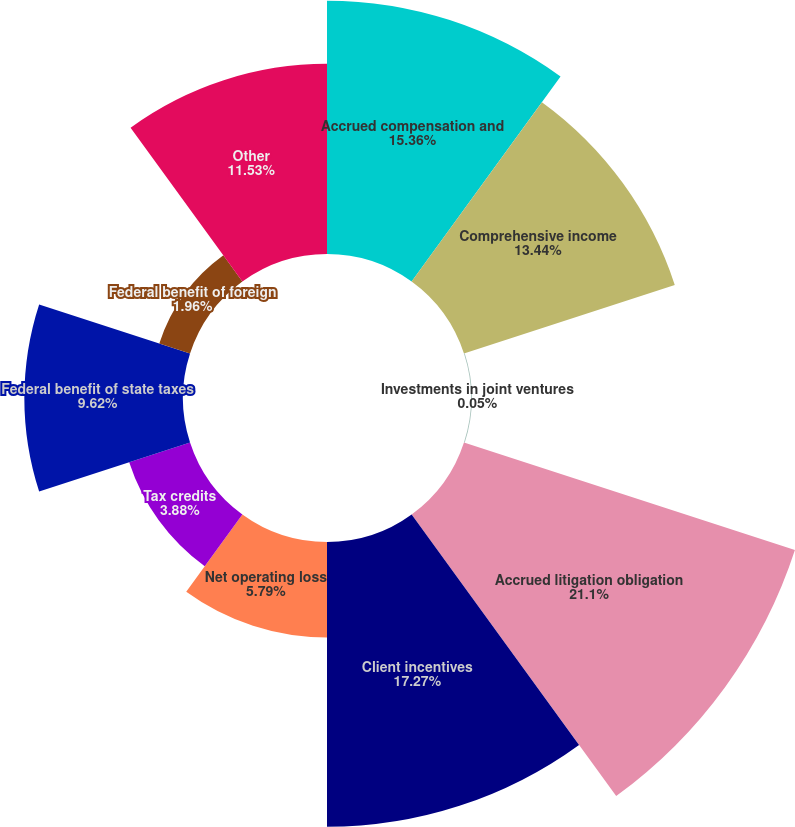Convert chart. <chart><loc_0><loc_0><loc_500><loc_500><pie_chart><fcel>Accrued compensation and<fcel>Comprehensive income<fcel>Investments in joint ventures<fcel>Accrued litigation obligation<fcel>Client incentives<fcel>Net operating loss<fcel>Tax credits<fcel>Federal benefit of state taxes<fcel>Federal benefit of foreign<fcel>Other<nl><fcel>15.36%<fcel>13.44%<fcel>0.05%<fcel>21.1%<fcel>17.27%<fcel>5.79%<fcel>3.88%<fcel>9.62%<fcel>1.96%<fcel>11.53%<nl></chart> 